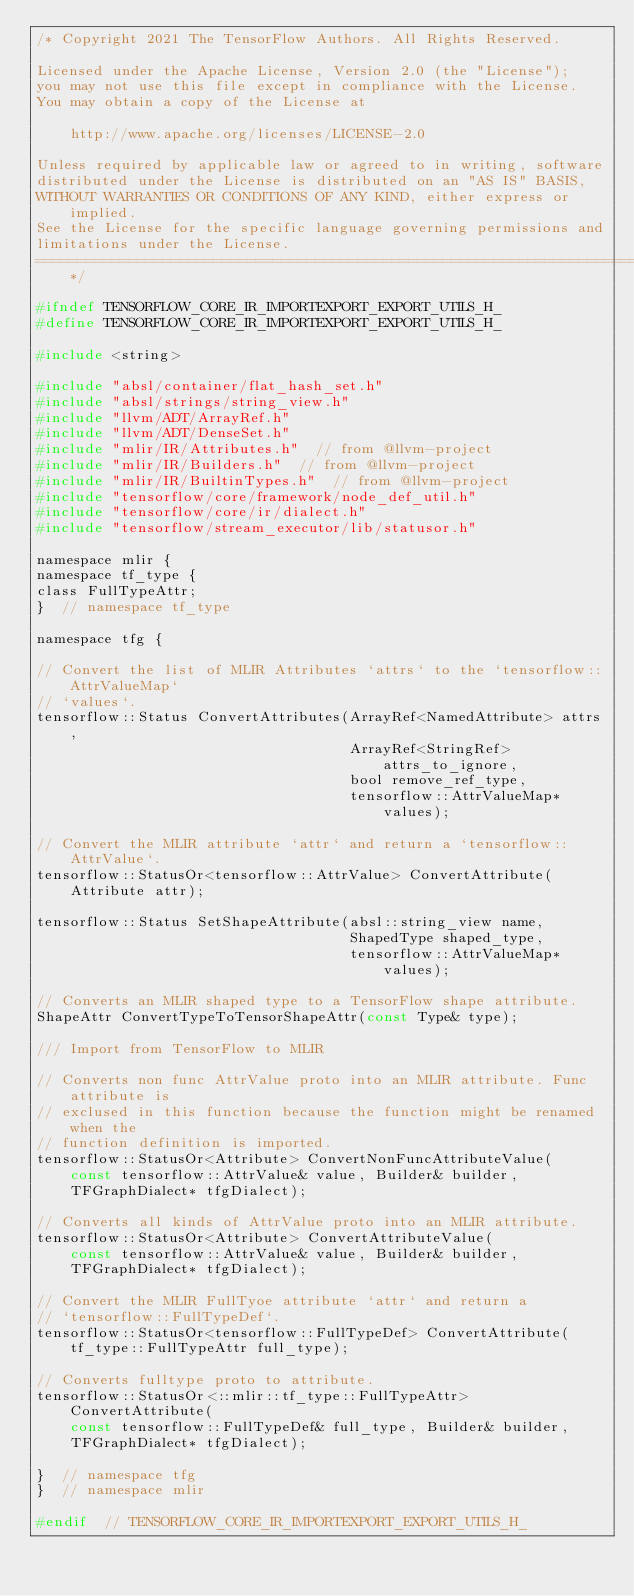<code> <loc_0><loc_0><loc_500><loc_500><_C_>/* Copyright 2021 The TensorFlow Authors. All Rights Reserved.

Licensed under the Apache License, Version 2.0 (the "License");
you may not use this file except in compliance with the License.
You may obtain a copy of the License at

    http://www.apache.org/licenses/LICENSE-2.0

Unless required by applicable law or agreed to in writing, software
distributed under the License is distributed on an "AS IS" BASIS,
WITHOUT WARRANTIES OR CONDITIONS OF ANY KIND, either express or implied.
See the License for the specific language governing permissions and
limitations under the License.
==============================================================================*/

#ifndef TENSORFLOW_CORE_IR_IMPORTEXPORT_EXPORT_UTILS_H_
#define TENSORFLOW_CORE_IR_IMPORTEXPORT_EXPORT_UTILS_H_

#include <string>

#include "absl/container/flat_hash_set.h"
#include "absl/strings/string_view.h"
#include "llvm/ADT/ArrayRef.h"
#include "llvm/ADT/DenseSet.h"
#include "mlir/IR/Attributes.h"  // from @llvm-project
#include "mlir/IR/Builders.h"  // from @llvm-project
#include "mlir/IR/BuiltinTypes.h"  // from @llvm-project
#include "tensorflow/core/framework/node_def_util.h"
#include "tensorflow/core/ir/dialect.h"
#include "tensorflow/stream_executor/lib/statusor.h"

namespace mlir {
namespace tf_type {
class FullTypeAttr;
}  // namespace tf_type

namespace tfg {

// Convert the list of MLIR Attributes `attrs` to the `tensorflow::AttrValueMap`
// `values`.
tensorflow::Status ConvertAttributes(ArrayRef<NamedAttribute> attrs,
                                     ArrayRef<StringRef> attrs_to_ignore,
                                     bool remove_ref_type,
                                     tensorflow::AttrValueMap* values);

// Convert the MLIR attribute `attr` and return a `tensorflow::AttrValue`.
tensorflow::StatusOr<tensorflow::AttrValue> ConvertAttribute(Attribute attr);

tensorflow::Status SetShapeAttribute(absl::string_view name,
                                     ShapedType shaped_type,
                                     tensorflow::AttrValueMap* values);

// Converts an MLIR shaped type to a TensorFlow shape attribute.
ShapeAttr ConvertTypeToTensorShapeAttr(const Type& type);

/// Import from TensorFlow to MLIR

// Converts non func AttrValue proto into an MLIR attribute. Func attribute is
// exclused in this function because the function might be renamed when the
// function definition is imported.
tensorflow::StatusOr<Attribute> ConvertNonFuncAttributeValue(
    const tensorflow::AttrValue& value, Builder& builder,
    TFGraphDialect* tfgDialect);

// Converts all kinds of AttrValue proto into an MLIR attribute.
tensorflow::StatusOr<Attribute> ConvertAttributeValue(
    const tensorflow::AttrValue& value, Builder& builder,
    TFGraphDialect* tfgDialect);

// Convert the MLIR FullTyoe attribute `attr` and return a
// `tensorflow::FullTypeDef`.
tensorflow::StatusOr<tensorflow::FullTypeDef> ConvertAttribute(
    tf_type::FullTypeAttr full_type);

// Converts fulltype proto to attribute.
tensorflow::StatusOr<::mlir::tf_type::FullTypeAttr> ConvertAttribute(
    const tensorflow::FullTypeDef& full_type, Builder& builder,
    TFGraphDialect* tfgDialect);

}  // namespace tfg
}  // namespace mlir

#endif  // TENSORFLOW_CORE_IR_IMPORTEXPORT_EXPORT_UTILS_H_
</code> 